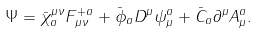<formula> <loc_0><loc_0><loc_500><loc_500>\Psi = \bar { \chi } _ { a } ^ { \mu \nu } F ^ { + a } _ { \mu \nu } + \bar { \phi } _ { a } D ^ { \mu } \psi _ { \mu } ^ { a } + \bar { C } _ { a } \partial ^ { \mu } A ^ { a } _ { \mu } .</formula> 